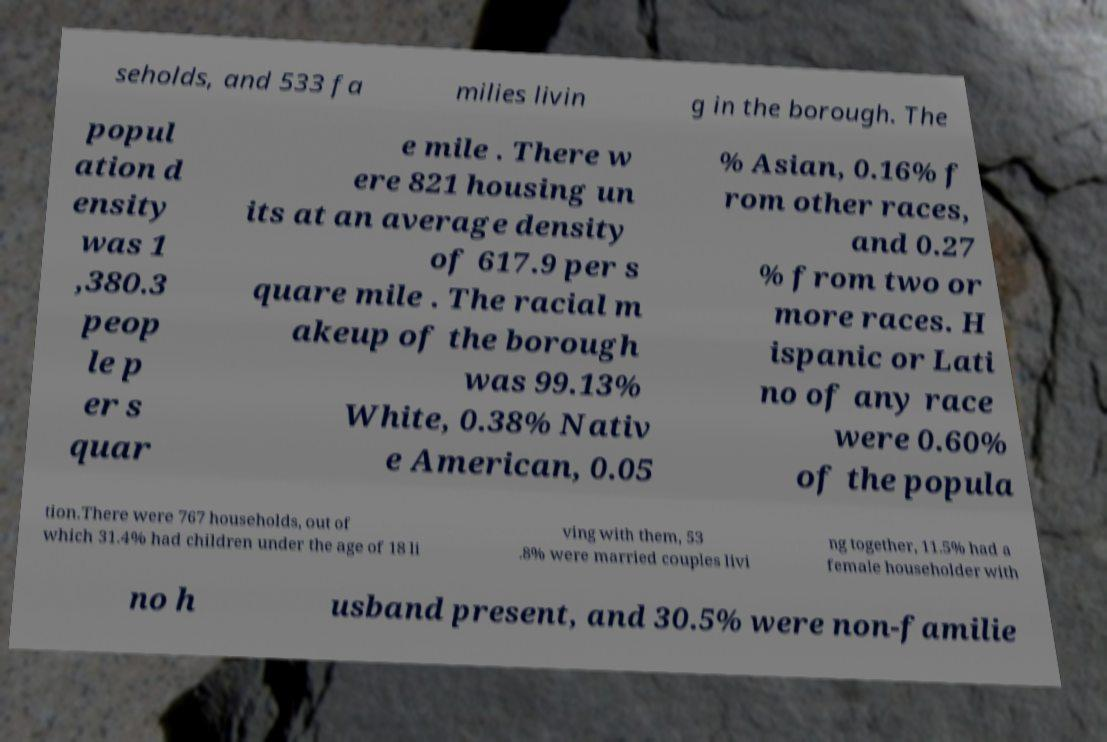Could you extract and type out the text from this image? seholds, and 533 fa milies livin g in the borough. The popul ation d ensity was 1 ,380.3 peop le p er s quar e mile . There w ere 821 housing un its at an average density of 617.9 per s quare mile . The racial m akeup of the borough was 99.13% White, 0.38% Nativ e American, 0.05 % Asian, 0.16% f rom other races, and 0.27 % from two or more races. H ispanic or Lati no of any race were 0.60% of the popula tion.There were 767 households, out of which 31.4% had children under the age of 18 li ving with them, 53 .8% were married couples livi ng together, 11.5% had a female householder with no h usband present, and 30.5% were non-familie 